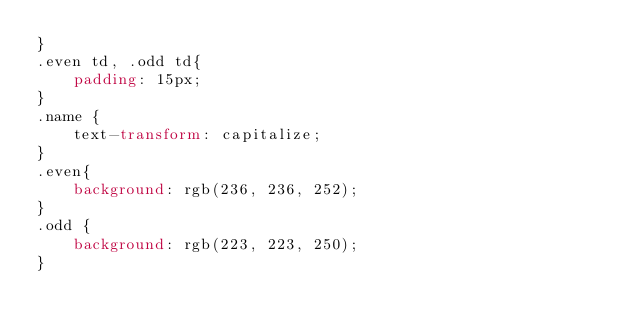<code> <loc_0><loc_0><loc_500><loc_500><_CSS_>}
.even td, .odd td{
    padding: 15px;
}
.name {
    text-transform: capitalize;
}
.even{
    background: rgb(236, 236, 252);
}
.odd {
    background: rgb(223, 223, 250);
}</code> 